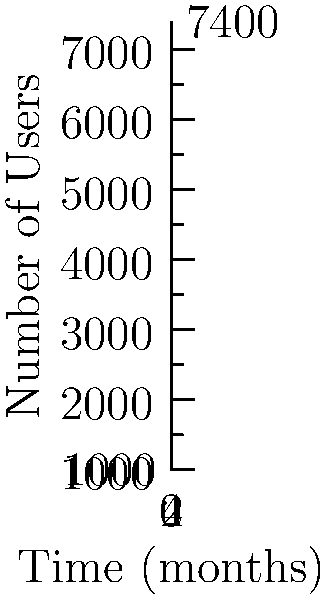A startup's user base growth can be modeled by the exponential function $N(t) = 1000e^{rt}$, where $N$ is the number of users, $t$ is time in months, and $r$ is the monthly growth rate. Given the graph showing the user base growing from 1000 to approximately 7400 over 4 months, calculate the monthly growth rate $r$. To find the monthly growth rate $r$, we can use the exponential growth formula and the given information:

1) Initial value: $N(0) = 1000$
2) Final value: $N(4) \approx 7400$
3) Time period: $t = 4$ months

Using the exponential growth formula:
$N(t) = 1000e^{rt}$

Substituting the values:
$7400 = 1000e^{r(4)}$

Dividing both sides by 1000:
$7.4 = e^{4r}$

Taking the natural logarithm of both sides:
$\ln(7.4) = 4r$

Solving for $r$:
$r = \frac{\ln(7.4)}{4}$

$r = \frac{2.0015}{4} = 0.5004$

Therefore, the monthly growth rate is approximately 0.5004, or about 50.04% per month.
Answer: $r \approx 0.5004$ or $50.04\%$ per month 